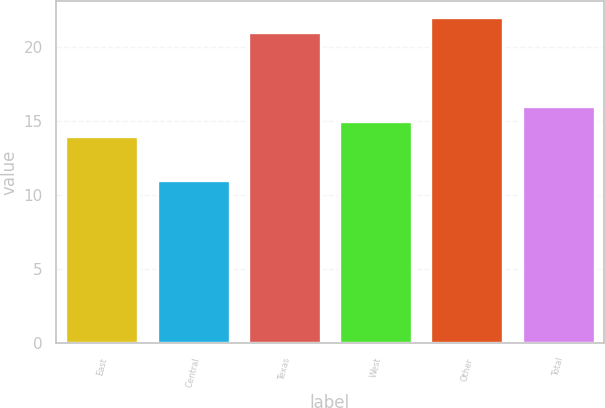<chart> <loc_0><loc_0><loc_500><loc_500><bar_chart><fcel>East<fcel>Central<fcel>Texas<fcel>West<fcel>Other<fcel>Total<nl><fcel>14<fcel>11<fcel>21<fcel>15<fcel>22<fcel>16<nl></chart> 